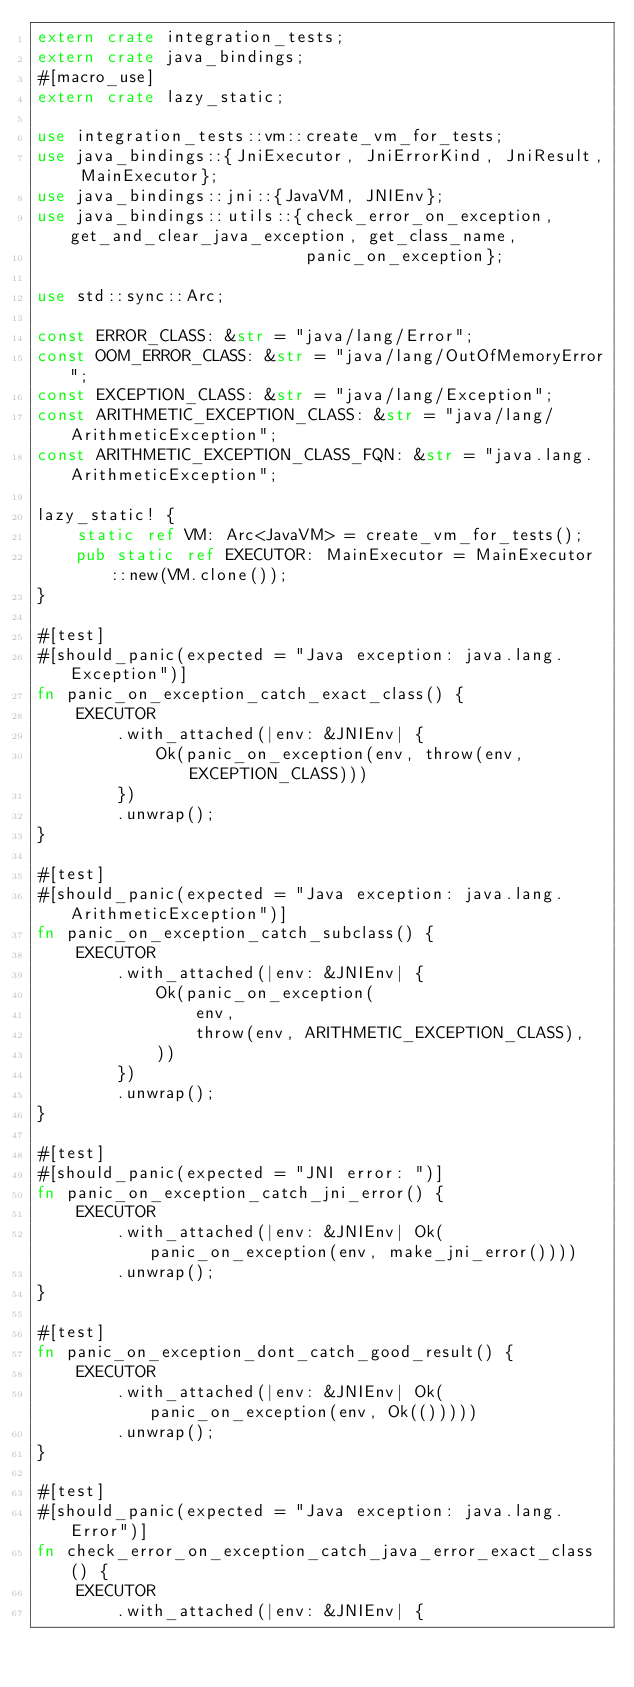<code> <loc_0><loc_0><loc_500><loc_500><_Rust_>extern crate integration_tests;
extern crate java_bindings;
#[macro_use]
extern crate lazy_static;

use integration_tests::vm::create_vm_for_tests;
use java_bindings::{JniExecutor, JniErrorKind, JniResult, MainExecutor};
use java_bindings::jni::{JavaVM, JNIEnv};
use java_bindings::utils::{check_error_on_exception, get_and_clear_java_exception, get_class_name,
                           panic_on_exception};

use std::sync::Arc;

const ERROR_CLASS: &str = "java/lang/Error";
const OOM_ERROR_CLASS: &str = "java/lang/OutOfMemoryError";
const EXCEPTION_CLASS: &str = "java/lang/Exception";
const ARITHMETIC_EXCEPTION_CLASS: &str = "java/lang/ArithmeticException";
const ARITHMETIC_EXCEPTION_CLASS_FQN: &str = "java.lang.ArithmeticException";

lazy_static! {
    static ref VM: Arc<JavaVM> = create_vm_for_tests();
    pub static ref EXECUTOR: MainExecutor = MainExecutor::new(VM.clone());
}

#[test]
#[should_panic(expected = "Java exception: java.lang.Exception")]
fn panic_on_exception_catch_exact_class() {
    EXECUTOR
        .with_attached(|env: &JNIEnv| {
            Ok(panic_on_exception(env, throw(env, EXCEPTION_CLASS)))
        })
        .unwrap();
}

#[test]
#[should_panic(expected = "Java exception: java.lang.ArithmeticException")]
fn panic_on_exception_catch_subclass() {
    EXECUTOR
        .with_attached(|env: &JNIEnv| {
            Ok(panic_on_exception(
                env,
                throw(env, ARITHMETIC_EXCEPTION_CLASS),
            ))
        })
        .unwrap();
}

#[test]
#[should_panic(expected = "JNI error: ")]
fn panic_on_exception_catch_jni_error() {
    EXECUTOR
        .with_attached(|env: &JNIEnv| Ok(panic_on_exception(env, make_jni_error())))
        .unwrap();
}

#[test]
fn panic_on_exception_dont_catch_good_result() {
    EXECUTOR
        .with_attached(|env: &JNIEnv| Ok(panic_on_exception(env, Ok(()))))
        .unwrap();
}

#[test]
#[should_panic(expected = "Java exception: java.lang.Error")]
fn check_error_on_exception_catch_java_error_exact_class() {
    EXECUTOR
        .with_attached(|env: &JNIEnv| {</code> 